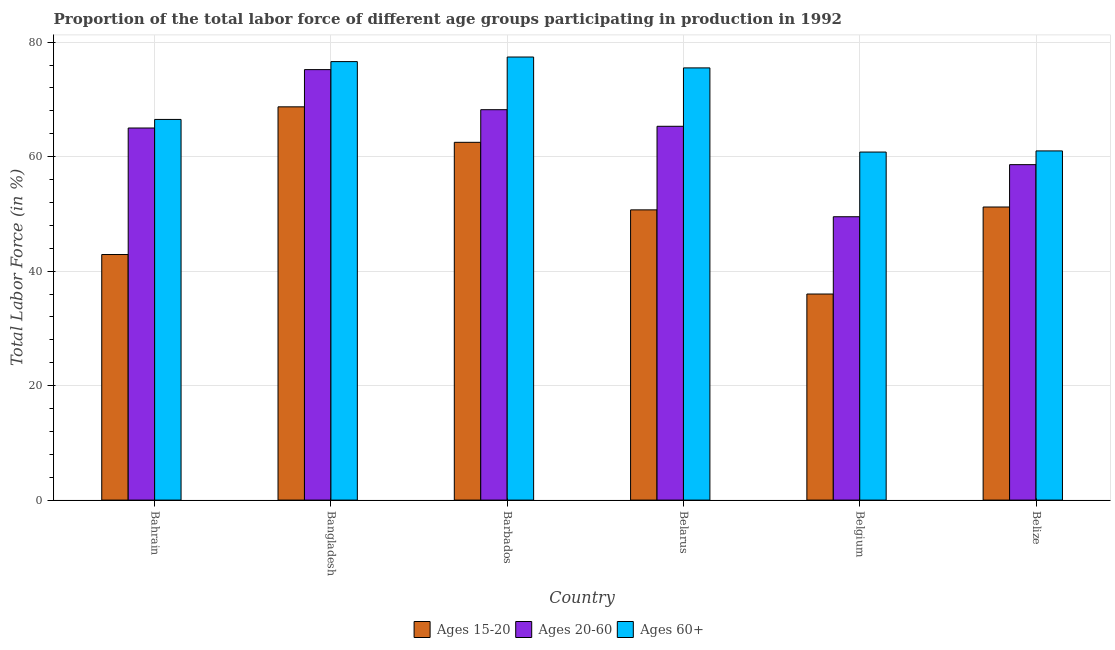How many different coloured bars are there?
Your answer should be very brief. 3. How many groups of bars are there?
Provide a short and direct response. 6. How many bars are there on the 4th tick from the left?
Your answer should be very brief. 3. How many bars are there on the 1st tick from the right?
Provide a short and direct response. 3. What is the label of the 6th group of bars from the left?
Give a very brief answer. Belize. What is the percentage of labor force within the age group 15-20 in Barbados?
Ensure brevity in your answer.  62.5. Across all countries, what is the maximum percentage of labor force above age 60?
Keep it short and to the point. 77.4. In which country was the percentage of labor force above age 60 maximum?
Make the answer very short. Barbados. In which country was the percentage of labor force above age 60 minimum?
Your answer should be very brief. Belgium. What is the total percentage of labor force within the age group 15-20 in the graph?
Your response must be concise. 312. What is the difference between the percentage of labor force above age 60 in Belarus and the percentage of labor force within the age group 20-60 in Belgium?
Provide a succinct answer. 26. What is the average percentage of labor force above age 60 per country?
Offer a terse response. 69.63. What is the ratio of the percentage of labor force within the age group 20-60 in Bahrain to that in Barbados?
Give a very brief answer. 0.95. Is the percentage of labor force within the age group 20-60 in Bahrain less than that in Belarus?
Offer a very short reply. Yes. What is the difference between the highest and the second highest percentage of labor force above age 60?
Provide a short and direct response. 0.8. What is the difference between the highest and the lowest percentage of labor force above age 60?
Keep it short and to the point. 16.6. What does the 2nd bar from the left in Bahrain represents?
Provide a succinct answer. Ages 20-60. What does the 1st bar from the right in Bahrain represents?
Your response must be concise. Ages 60+. What is the difference between two consecutive major ticks on the Y-axis?
Offer a very short reply. 20. Does the graph contain grids?
Ensure brevity in your answer.  Yes. Where does the legend appear in the graph?
Ensure brevity in your answer.  Bottom center. How many legend labels are there?
Provide a short and direct response. 3. How are the legend labels stacked?
Provide a succinct answer. Horizontal. What is the title of the graph?
Offer a terse response. Proportion of the total labor force of different age groups participating in production in 1992. Does "Neonatal" appear as one of the legend labels in the graph?
Your answer should be compact. No. What is the Total Labor Force (in %) of Ages 15-20 in Bahrain?
Provide a short and direct response. 42.9. What is the Total Labor Force (in %) of Ages 60+ in Bahrain?
Give a very brief answer. 66.5. What is the Total Labor Force (in %) of Ages 15-20 in Bangladesh?
Your answer should be compact. 68.7. What is the Total Labor Force (in %) in Ages 20-60 in Bangladesh?
Give a very brief answer. 75.2. What is the Total Labor Force (in %) of Ages 60+ in Bangladesh?
Offer a terse response. 76.6. What is the Total Labor Force (in %) in Ages 15-20 in Barbados?
Provide a succinct answer. 62.5. What is the Total Labor Force (in %) of Ages 20-60 in Barbados?
Give a very brief answer. 68.2. What is the Total Labor Force (in %) of Ages 60+ in Barbados?
Your response must be concise. 77.4. What is the Total Labor Force (in %) of Ages 15-20 in Belarus?
Your answer should be compact. 50.7. What is the Total Labor Force (in %) of Ages 20-60 in Belarus?
Provide a succinct answer. 65.3. What is the Total Labor Force (in %) in Ages 60+ in Belarus?
Provide a short and direct response. 75.5. What is the Total Labor Force (in %) of Ages 20-60 in Belgium?
Provide a succinct answer. 49.5. What is the Total Labor Force (in %) in Ages 60+ in Belgium?
Your answer should be compact. 60.8. What is the Total Labor Force (in %) in Ages 15-20 in Belize?
Offer a very short reply. 51.2. What is the Total Labor Force (in %) of Ages 20-60 in Belize?
Your answer should be compact. 58.6. What is the Total Labor Force (in %) in Ages 60+ in Belize?
Ensure brevity in your answer.  61. Across all countries, what is the maximum Total Labor Force (in %) in Ages 15-20?
Your answer should be compact. 68.7. Across all countries, what is the maximum Total Labor Force (in %) of Ages 20-60?
Provide a succinct answer. 75.2. Across all countries, what is the maximum Total Labor Force (in %) in Ages 60+?
Offer a terse response. 77.4. Across all countries, what is the minimum Total Labor Force (in %) in Ages 15-20?
Offer a terse response. 36. Across all countries, what is the minimum Total Labor Force (in %) in Ages 20-60?
Give a very brief answer. 49.5. Across all countries, what is the minimum Total Labor Force (in %) of Ages 60+?
Offer a very short reply. 60.8. What is the total Total Labor Force (in %) in Ages 15-20 in the graph?
Your response must be concise. 312. What is the total Total Labor Force (in %) in Ages 20-60 in the graph?
Provide a succinct answer. 381.8. What is the total Total Labor Force (in %) in Ages 60+ in the graph?
Your answer should be very brief. 417.8. What is the difference between the Total Labor Force (in %) in Ages 15-20 in Bahrain and that in Bangladesh?
Give a very brief answer. -25.8. What is the difference between the Total Labor Force (in %) of Ages 60+ in Bahrain and that in Bangladesh?
Make the answer very short. -10.1. What is the difference between the Total Labor Force (in %) in Ages 15-20 in Bahrain and that in Barbados?
Your answer should be very brief. -19.6. What is the difference between the Total Labor Force (in %) of Ages 60+ in Bahrain and that in Barbados?
Give a very brief answer. -10.9. What is the difference between the Total Labor Force (in %) of Ages 15-20 in Bahrain and that in Belgium?
Your answer should be very brief. 6.9. What is the difference between the Total Labor Force (in %) in Ages 60+ in Bahrain and that in Belgium?
Offer a terse response. 5.7. What is the difference between the Total Labor Force (in %) of Ages 15-20 in Bahrain and that in Belize?
Your answer should be very brief. -8.3. What is the difference between the Total Labor Force (in %) of Ages 20-60 in Bahrain and that in Belize?
Make the answer very short. 6.4. What is the difference between the Total Labor Force (in %) of Ages 15-20 in Bangladesh and that in Barbados?
Provide a succinct answer. 6.2. What is the difference between the Total Labor Force (in %) in Ages 15-20 in Bangladesh and that in Belgium?
Offer a terse response. 32.7. What is the difference between the Total Labor Force (in %) of Ages 20-60 in Bangladesh and that in Belgium?
Ensure brevity in your answer.  25.7. What is the difference between the Total Labor Force (in %) of Ages 15-20 in Barbados and that in Belarus?
Give a very brief answer. 11.8. What is the difference between the Total Labor Force (in %) of Ages 60+ in Barbados and that in Belarus?
Provide a succinct answer. 1.9. What is the difference between the Total Labor Force (in %) of Ages 15-20 in Barbados and that in Belgium?
Ensure brevity in your answer.  26.5. What is the difference between the Total Labor Force (in %) in Ages 20-60 in Barbados and that in Belgium?
Make the answer very short. 18.7. What is the difference between the Total Labor Force (in %) of Ages 15-20 in Barbados and that in Belize?
Give a very brief answer. 11.3. What is the difference between the Total Labor Force (in %) of Ages 20-60 in Barbados and that in Belize?
Offer a very short reply. 9.6. What is the difference between the Total Labor Force (in %) in Ages 60+ in Barbados and that in Belize?
Provide a short and direct response. 16.4. What is the difference between the Total Labor Force (in %) of Ages 15-20 in Belarus and that in Belgium?
Ensure brevity in your answer.  14.7. What is the difference between the Total Labor Force (in %) of Ages 60+ in Belarus and that in Belgium?
Ensure brevity in your answer.  14.7. What is the difference between the Total Labor Force (in %) of Ages 20-60 in Belarus and that in Belize?
Provide a short and direct response. 6.7. What is the difference between the Total Labor Force (in %) of Ages 60+ in Belarus and that in Belize?
Your answer should be compact. 14.5. What is the difference between the Total Labor Force (in %) of Ages 15-20 in Belgium and that in Belize?
Ensure brevity in your answer.  -15.2. What is the difference between the Total Labor Force (in %) of Ages 20-60 in Belgium and that in Belize?
Provide a short and direct response. -9.1. What is the difference between the Total Labor Force (in %) in Ages 15-20 in Bahrain and the Total Labor Force (in %) in Ages 20-60 in Bangladesh?
Your answer should be very brief. -32.3. What is the difference between the Total Labor Force (in %) in Ages 15-20 in Bahrain and the Total Labor Force (in %) in Ages 60+ in Bangladesh?
Ensure brevity in your answer.  -33.7. What is the difference between the Total Labor Force (in %) of Ages 20-60 in Bahrain and the Total Labor Force (in %) of Ages 60+ in Bangladesh?
Provide a short and direct response. -11.6. What is the difference between the Total Labor Force (in %) in Ages 15-20 in Bahrain and the Total Labor Force (in %) in Ages 20-60 in Barbados?
Offer a very short reply. -25.3. What is the difference between the Total Labor Force (in %) in Ages 15-20 in Bahrain and the Total Labor Force (in %) in Ages 60+ in Barbados?
Make the answer very short. -34.5. What is the difference between the Total Labor Force (in %) in Ages 15-20 in Bahrain and the Total Labor Force (in %) in Ages 20-60 in Belarus?
Offer a terse response. -22.4. What is the difference between the Total Labor Force (in %) of Ages 15-20 in Bahrain and the Total Labor Force (in %) of Ages 60+ in Belarus?
Offer a terse response. -32.6. What is the difference between the Total Labor Force (in %) of Ages 15-20 in Bahrain and the Total Labor Force (in %) of Ages 60+ in Belgium?
Your answer should be compact. -17.9. What is the difference between the Total Labor Force (in %) of Ages 15-20 in Bahrain and the Total Labor Force (in %) of Ages 20-60 in Belize?
Give a very brief answer. -15.7. What is the difference between the Total Labor Force (in %) of Ages 15-20 in Bahrain and the Total Labor Force (in %) of Ages 60+ in Belize?
Your response must be concise. -18.1. What is the difference between the Total Labor Force (in %) in Ages 15-20 in Bangladesh and the Total Labor Force (in %) in Ages 60+ in Barbados?
Provide a succinct answer. -8.7. What is the difference between the Total Labor Force (in %) in Ages 20-60 in Bangladesh and the Total Labor Force (in %) in Ages 60+ in Barbados?
Your answer should be compact. -2.2. What is the difference between the Total Labor Force (in %) in Ages 15-20 in Bangladesh and the Total Labor Force (in %) in Ages 20-60 in Belarus?
Your answer should be compact. 3.4. What is the difference between the Total Labor Force (in %) in Ages 15-20 in Bangladesh and the Total Labor Force (in %) in Ages 20-60 in Belgium?
Offer a very short reply. 19.2. What is the difference between the Total Labor Force (in %) in Ages 20-60 in Bangladesh and the Total Labor Force (in %) in Ages 60+ in Belgium?
Give a very brief answer. 14.4. What is the difference between the Total Labor Force (in %) in Ages 15-20 in Bangladesh and the Total Labor Force (in %) in Ages 60+ in Belize?
Your answer should be very brief. 7.7. What is the difference between the Total Labor Force (in %) of Ages 20-60 in Bangladesh and the Total Labor Force (in %) of Ages 60+ in Belize?
Give a very brief answer. 14.2. What is the difference between the Total Labor Force (in %) in Ages 15-20 in Barbados and the Total Labor Force (in %) in Ages 20-60 in Belarus?
Your answer should be compact. -2.8. What is the difference between the Total Labor Force (in %) of Ages 15-20 in Barbados and the Total Labor Force (in %) of Ages 20-60 in Belgium?
Provide a succinct answer. 13. What is the difference between the Total Labor Force (in %) in Ages 15-20 in Barbados and the Total Labor Force (in %) in Ages 60+ in Belgium?
Your response must be concise. 1.7. What is the difference between the Total Labor Force (in %) in Ages 15-20 in Barbados and the Total Labor Force (in %) in Ages 60+ in Belize?
Offer a very short reply. 1.5. What is the difference between the Total Labor Force (in %) of Ages 20-60 in Barbados and the Total Labor Force (in %) of Ages 60+ in Belize?
Ensure brevity in your answer.  7.2. What is the difference between the Total Labor Force (in %) in Ages 15-20 in Belarus and the Total Labor Force (in %) in Ages 20-60 in Belgium?
Offer a terse response. 1.2. What is the difference between the Total Labor Force (in %) in Ages 15-20 in Belgium and the Total Labor Force (in %) in Ages 20-60 in Belize?
Make the answer very short. -22.6. What is the difference between the Total Labor Force (in %) in Ages 15-20 in Belgium and the Total Labor Force (in %) in Ages 60+ in Belize?
Keep it short and to the point. -25. What is the difference between the Total Labor Force (in %) of Ages 20-60 in Belgium and the Total Labor Force (in %) of Ages 60+ in Belize?
Make the answer very short. -11.5. What is the average Total Labor Force (in %) in Ages 15-20 per country?
Ensure brevity in your answer.  52. What is the average Total Labor Force (in %) of Ages 20-60 per country?
Provide a succinct answer. 63.63. What is the average Total Labor Force (in %) of Ages 60+ per country?
Your answer should be very brief. 69.63. What is the difference between the Total Labor Force (in %) in Ages 15-20 and Total Labor Force (in %) in Ages 20-60 in Bahrain?
Your answer should be very brief. -22.1. What is the difference between the Total Labor Force (in %) in Ages 15-20 and Total Labor Force (in %) in Ages 60+ in Bahrain?
Provide a short and direct response. -23.6. What is the difference between the Total Labor Force (in %) in Ages 20-60 and Total Labor Force (in %) in Ages 60+ in Bahrain?
Offer a terse response. -1.5. What is the difference between the Total Labor Force (in %) in Ages 15-20 and Total Labor Force (in %) in Ages 20-60 in Bangladesh?
Ensure brevity in your answer.  -6.5. What is the difference between the Total Labor Force (in %) of Ages 15-20 and Total Labor Force (in %) of Ages 60+ in Bangladesh?
Provide a short and direct response. -7.9. What is the difference between the Total Labor Force (in %) in Ages 15-20 and Total Labor Force (in %) in Ages 20-60 in Barbados?
Offer a very short reply. -5.7. What is the difference between the Total Labor Force (in %) of Ages 15-20 and Total Labor Force (in %) of Ages 60+ in Barbados?
Ensure brevity in your answer.  -14.9. What is the difference between the Total Labor Force (in %) of Ages 15-20 and Total Labor Force (in %) of Ages 20-60 in Belarus?
Provide a succinct answer. -14.6. What is the difference between the Total Labor Force (in %) in Ages 15-20 and Total Labor Force (in %) in Ages 60+ in Belarus?
Provide a succinct answer. -24.8. What is the difference between the Total Labor Force (in %) of Ages 15-20 and Total Labor Force (in %) of Ages 60+ in Belgium?
Your answer should be very brief. -24.8. What is the difference between the Total Labor Force (in %) of Ages 15-20 and Total Labor Force (in %) of Ages 20-60 in Belize?
Ensure brevity in your answer.  -7.4. What is the difference between the Total Labor Force (in %) of Ages 20-60 and Total Labor Force (in %) of Ages 60+ in Belize?
Your answer should be very brief. -2.4. What is the ratio of the Total Labor Force (in %) in Ages 15-20 in Bahrain to that in Bangladesh?
Provide a succinct answer. 0.62. What is the ratio of the Total Labor Force (in %) in Ages 20-60 in Bahrain to that in Bangladesh?
Provide a succinct answer. 0.86. What is the ratio of the Total Labor Force (in %) of Ages 60+ in Bahrain to that in Bangladesh?
Make the answer very short. 0.87. What is the ratio of the Total Labor Force (in %) in Ages 15-20 in Bahrain to that in Barbados?
Provide a succinct answer. 0.69. What is the ratio of the Total Labor Force (in %) in Ages 20-60 in Bahrain to that in Barbados?
Make the answer very short. 0.95. What is the ratio of the Total Labor Force (in %) of Ages 60+ in Bahrain to that in Barbados?
Keep it short and to the point. 0.86. What is the ratio of the Total Labor Force (in %) of Ages 15-20 in Bahrain to that in Belarus?
Offer a very short reply. 0.85. What is the ratio of the Total Labor Force (in %) of Ages 60+ in Bahrain to that in Belarus?
Provide a succinct answer. 0.88. What is the ratio of the Total Labor Force (in %) of Ages 15-20 in Bahrain to that in Belgium?
Your answer should be compact. 1.19. What is the ratio of the Total Labor Force (in %) in Ages 20-60 in Bahrain to that in Belgium?
Keep it short and to the point. 1.31. What is the ratio of the Total Labor Force (in %) of Ages 60+ in Bahrain to that in Belgium?
Offer a very short reply. 1.09. What is the ratio of the Total Labor Force (in %) of Ages 15-20 in Bahrain to that in Belize?
Offer a terse response. 0.84. What is the ratio of the Total Labor Force (in %) in Ages 20-60 in Bahrain to that in Belize?
Provide a succinct answer. 1.11. What is the ratio of the Total Labor Force (in %) in Ages 60+ in Bahrain to that in Belize?
Your answer should be compact. 1.09. What is the ratio of the Total Labor Force (in %) in Ages 15-20 in Bangladesh to that in Barbados?
Keep it short and to the point. 1.1. What is the ratio of the Total Labor Force (in %) of Ages 20-60 in Bangladesh to that in Barbados?
Provide a short and direct response. 1.1. What is the ratio of the Total Labor Force (in %) of Ages 60+ in Bangladesh to that in Barbados?
Provide a succinct answer. 0.99. What is the ratio of the Total Labor Force (in %) of Ages 15-20 in Bangladesh to that in Belarus?
Offer a very short reply. 1.35. What is the ratio of the Total Labor Force (in %) of Ages 20-60 in Bangladesh to that in Belarus?
Ensure brevity in your answer.  1.15. What is the ratio of the Total Labor Force (in %) in Ages 60+ in Bangladesh to that in Belarus?
Keep it short and to the point. 1.01. What is the ratio of the Total Labor Force (in %) in Ages 15-20 in Bangladesh to that in Belgium?
Your answer should be compact. 1.91. What is the ratio of the Total Labor Force (in %) of Ages 20-60 in Bangladesh to that in Belgium?
Provide a short and direct response. 1.52. What is the ratio of the Total Labor Force (in %) in Ages 60+ in Bangladesh to that in Belgium?
Provide a succinct answer. 1.26. What is the ratio of the Total Labor Force (in %) of Ages 15-20 in Bangladesh to that in Belize?
Offer a very short reply. 1.34. What is the ratio of the Total Labor Force (in %) in Ages 20-60 in Bangladesh to that in Belize?
Provide a succinct answer. 1.28. What is the ratio of the Total Labor Force (in %) of Ages 60+ in Bangladesh to that in Belize?
Keep it short and to the point. 1.26. What is the ratio of the Total Labor Force (in %) of Ages 15-20 in Barbados to that in Belarus?
Make the answer very short. 1.23. What is the ratio of the Total Labor Force (in %) of Ages 20-60 in Barbados to that in Belarus?
Provide a succinct answer. 1.04. What is the ratio of the Total Labor Force (in %) of Ages 60+ in Barbados to that in Belarus?
Your answer should be compact. 1.03. What is the ratio of the Total Labor Force (in %) of Ages 15-20 in Barbados to that in Belgium?
Offer a very short reply. 1.74. What is the ratio of the Total Labor Force (in %) of Ages 20-60 in Barbados to that in Belgium?
Provide a short and direct response. 1.38. What is the ratio of the Total Labor Force (in %) in Ages 60+ in Barbados to that in Belgium?
Provide a succinct answer. 1.27. What is the ratio of the Total Labor Force (in %) of Ages 15-20 in Barbados to that in Belize?
Your answer should be very brief. 1.22. What is the ratio of the Total Labor Force (in %) of Ages 20-60 in Barbados to that in Belize?
Keep it short and to the point. 1.16. What is the ratio of the Total Labor Force (in %) in Ages 60+ in Barbados to that in Belize?
Offer a terse response. 1.27. What is the ratio of the Total Labor Force (in %) of Ages 15-20 in Belarus to that in Belgium?
Your answer should be compact. 1.41. What is the ratio of the Total Labor Force (in %) in Ages 20-60 in Belarus to that in Belgium?
Provide a short and direct response. 1.32. What is the ratio of the Total Labor Force (in %) of Ages 60+ in Belarus to that in Belgium?
Your answer should be compact. 1.24. What is the ratio of the Total Labor Force (in %) in Ages 15-20 in Belarus to that in Belize?
Give a very brief answer. 0.99. What is the ratio of the Total Labor Force (in %) in Ages 20-60 in Belarus to that in Belize?
Provide a succinct answer. 1.11. What is the ratio of the Total Labor Force (in %) in Ages 60+ in Belarus to that in Belize?
Offer a terse response. 1.24. What is the ratio of the Total Labor Force (in %) in Ages 15-20 in Belgium to that in Belize?
Provide a succinct answer. 0.7. What is the ratio of the Total Labor Force (in %) in Ages 20-60 in Belgium to that in Belize?
Keep it short and to the point. 0.84. What is the ratio of the Total Labor Force (in %) in Ages 60+ in Belgium to that in Belize?
Make the answer very short. 1. What is the difference between the highest and the second highest Total Labor Force (in %) in Ages 60+?
Your answer should be compact. 0.8. What is the difference between the highest and the lowest Total Labor Force (in %) in Ages 15-20?
Offer a very short reply. 32.7. What is the difference between the highest and the lowest Total Labor Force (in %) in Ages 20-60?
Offer a very short reply. 25.7. What is the difference between the highest and the lowest Total Labor Force (in %) of Ages 60+?
Offer a terse response. 16.6. 